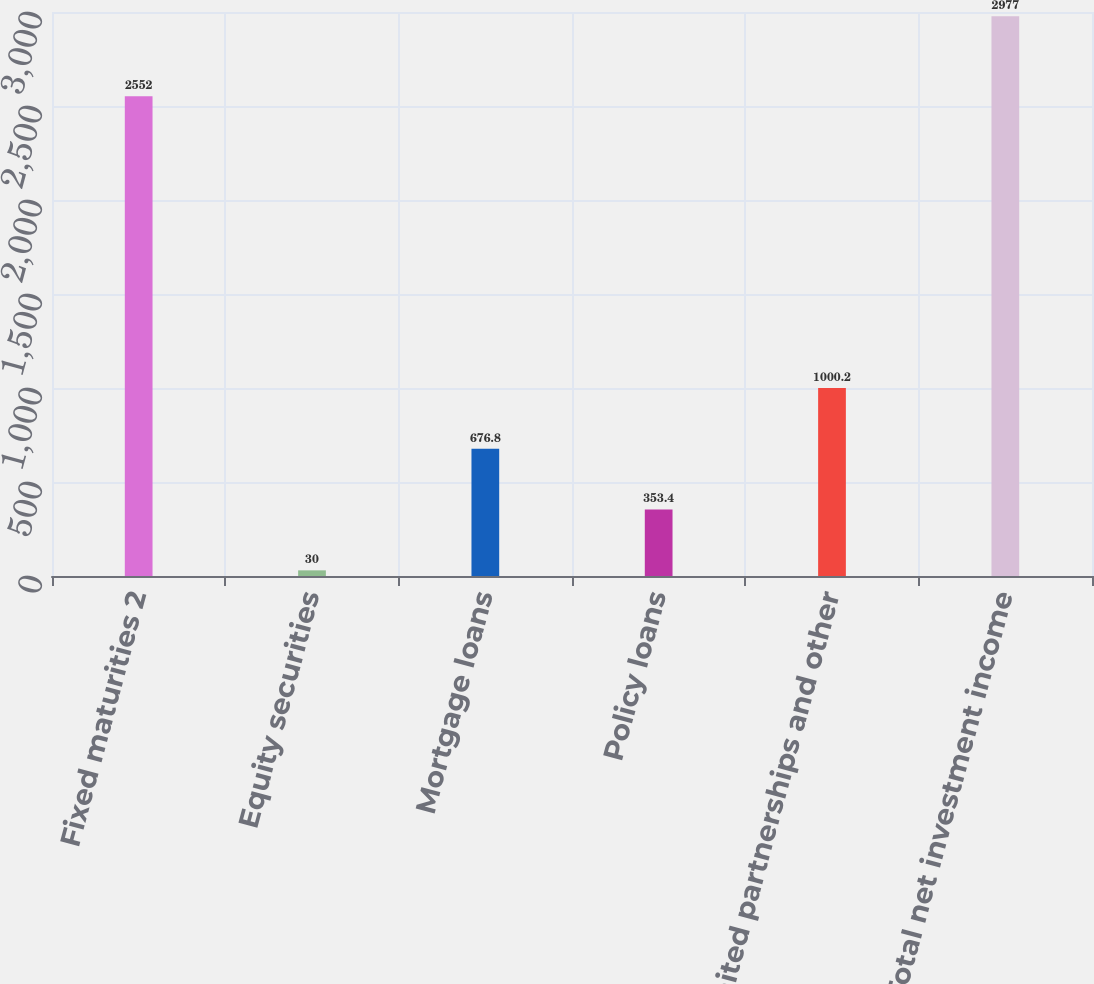Convert chart to OTSL. <chart><loc_0><loc_0><loc_500><loc_500><bar_chart><fcel>Fixed maturities 2<fcel>Equity securities<fcel>Mortgage loans<fcel>Policy loans<fcel>Limited partnerships and other<fcel>Total net investment income<nl><fcel>2552<fcel>30<fcel>676.8<fcel>353.4<fcel>1000.2<fcel>2977<nl></chart> 